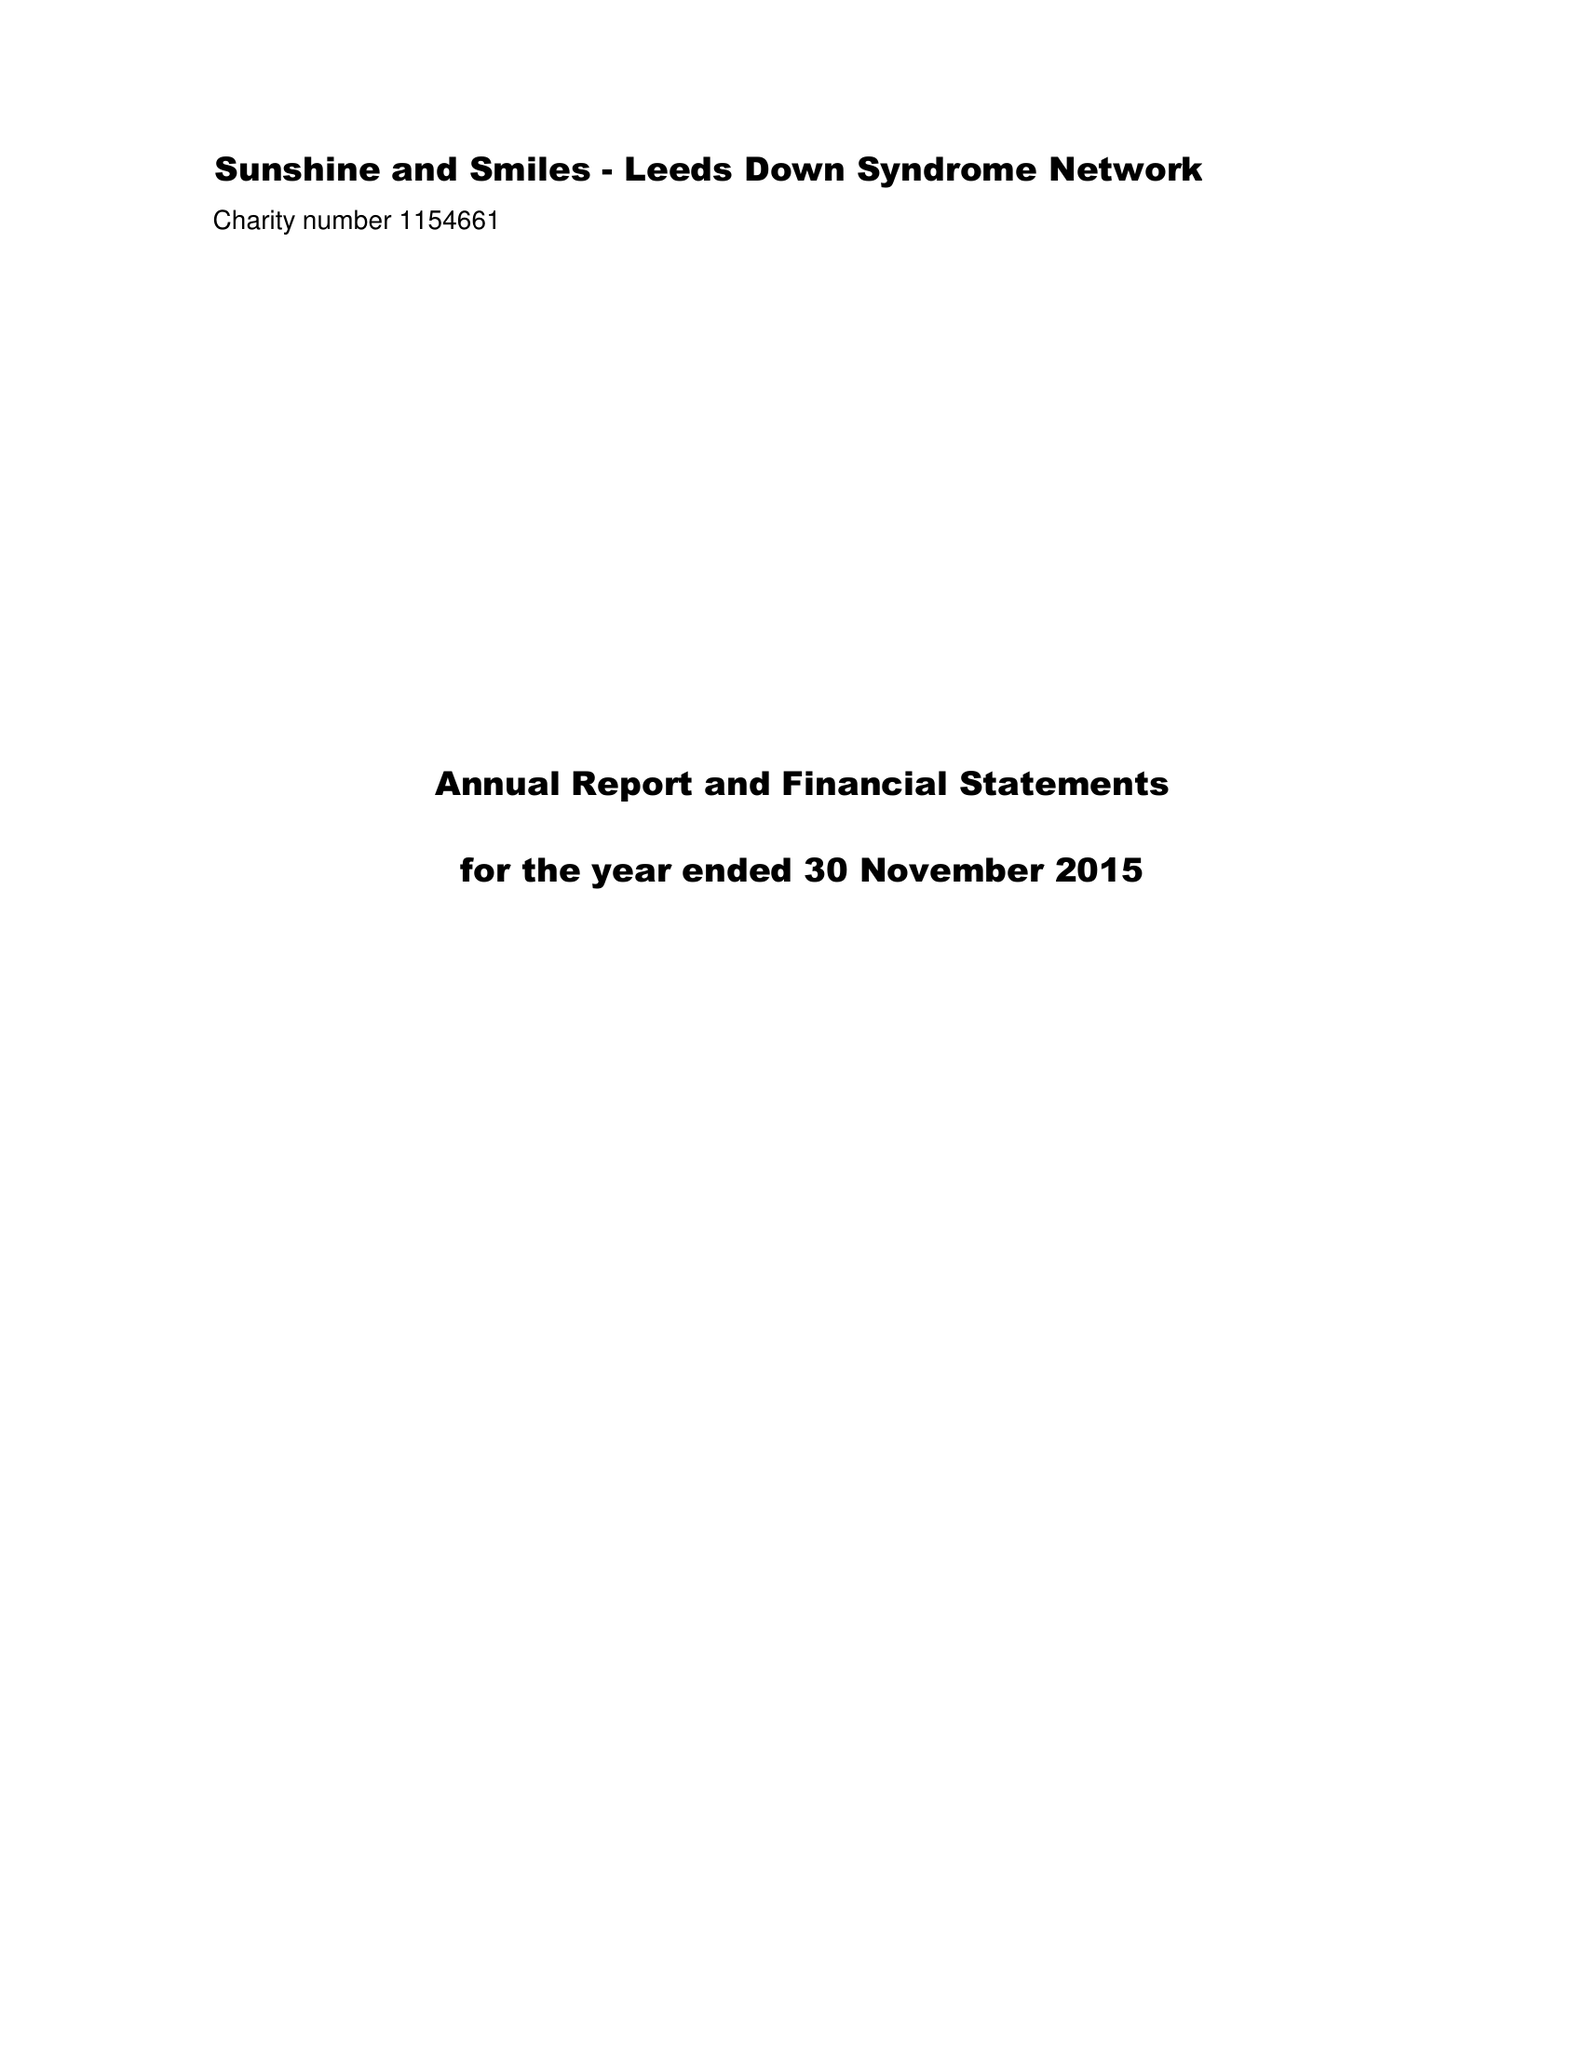What is the value for the charity_number?
Answer the question using a single word or phrase. 1154661 